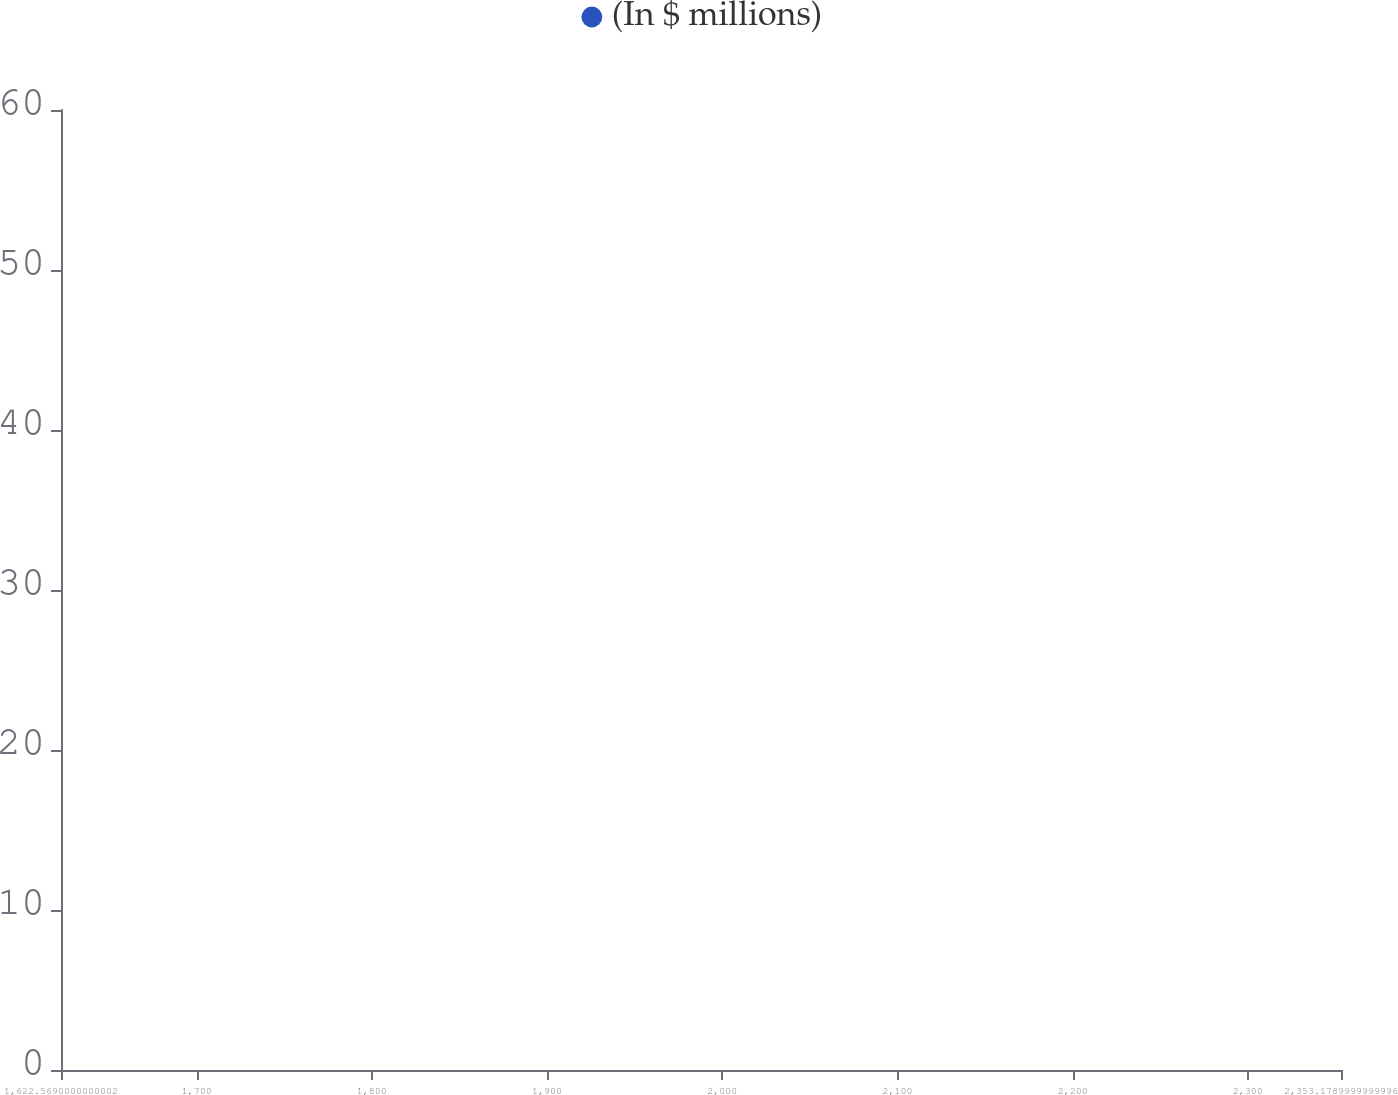Convert chart to OTSL. <chart><loc_0><loc_0><loc_500><loc_500><line_chart><ecel><fcel>(In $ millions)<nl><fcel>1695.63<fcel>57.82<nl><fcel>1895.75<fcel>45.87<nl><fcel>1962.25<fcel>28.99<nl><fcel>2359.74<fcel>16.97<nl><fcel>2426.24<fcel>8.43<nl></chart> 